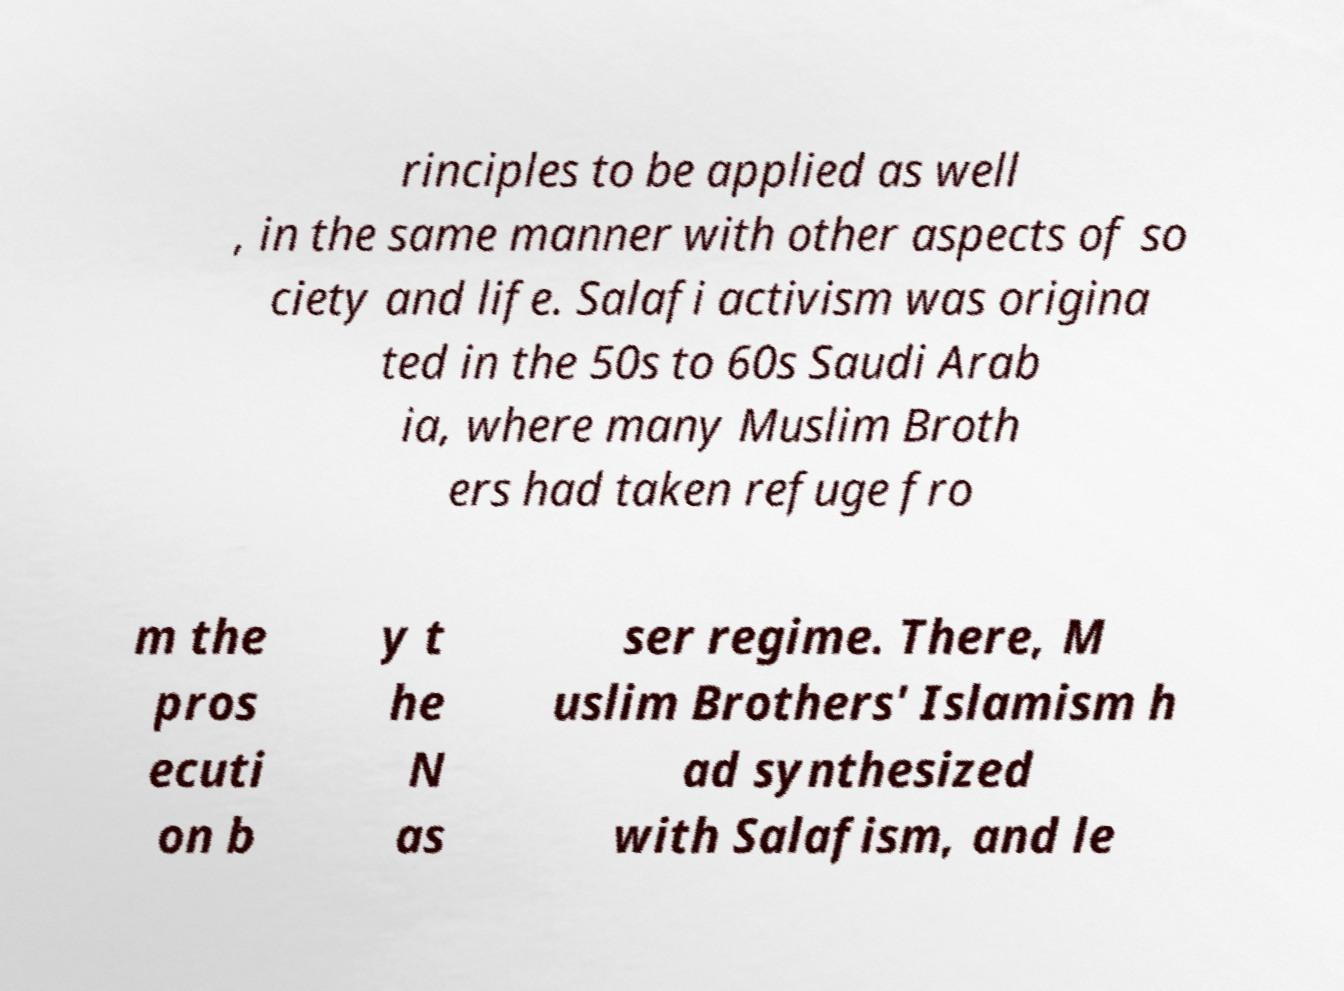For documentation purposes, I need the text within this image transcribed. Could you provide that? rinciples to be applied as well , in the same manner with other aspects of so ciety and life. Salafi activism was origina ted in the 50s to 60s Saudi Arab ia, where many Muslim Broth ers had taken refuge fro m the pros ecuti on b y t he N as ser regime. There, M uslim Brothers' Islamism h ad synthesized with Salafism, and le 